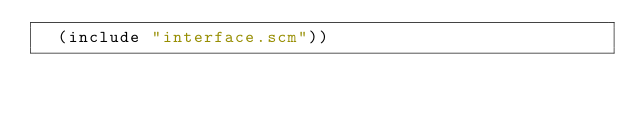<code> <loc_0><loc_0><loc_500><loc_500><_Scheme_>  (include "interface.scm"))
</code> 